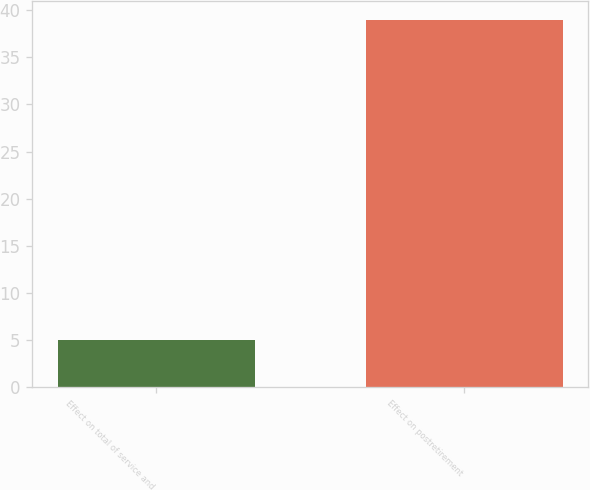<chart> <loc_0><loc_0><loc_500><loc_500><bar_chart><fcel>Effect on total of service and<fcel>Effect on postretirement<nl><fcel>5<fcel>39<nl></chart> 